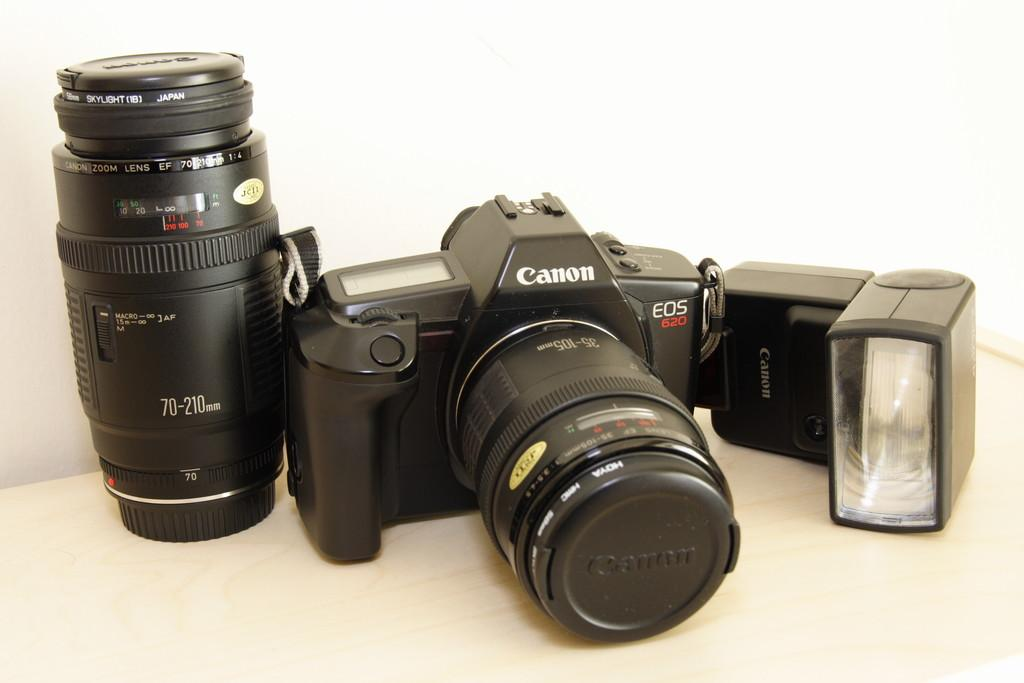What is the main subject of the image? The main subject of the image is a black canon camera. Are there any additional camera components visible in the image? Yes, there is a black lens beside the camera. What other object can be seen on the left side of the image? There is a flashlight on the left side of the image. How many roses are present in the image? There are no roses present in the image. What type of class is being taught in the image? There is no class or teaching activity depicted in the image. 